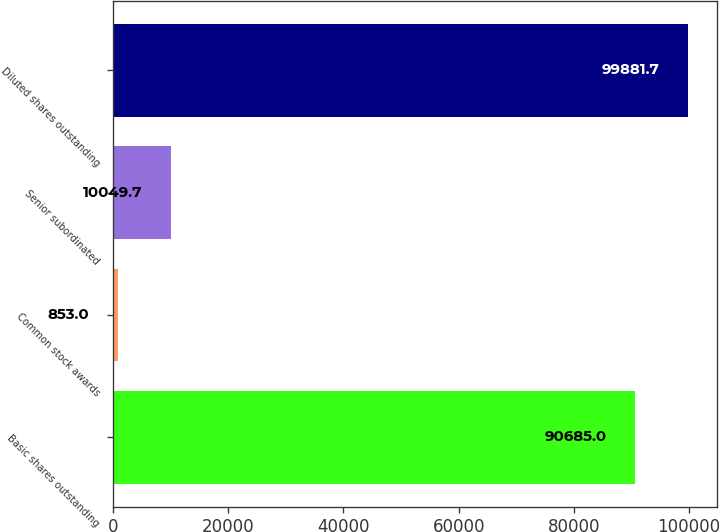Convert chart to OTSL. <chart><loc_0><loc_0><loc_500><loc_500><bar_chart><fcel>Basic shares outstanding<fcel>Common stock awards<fcel>Senior subordinated<fcel>Diluted shares outstanding<nl><fcel>90685<fcel>853<fcel>10049.7<fcel>99881.7<nl></chart> 